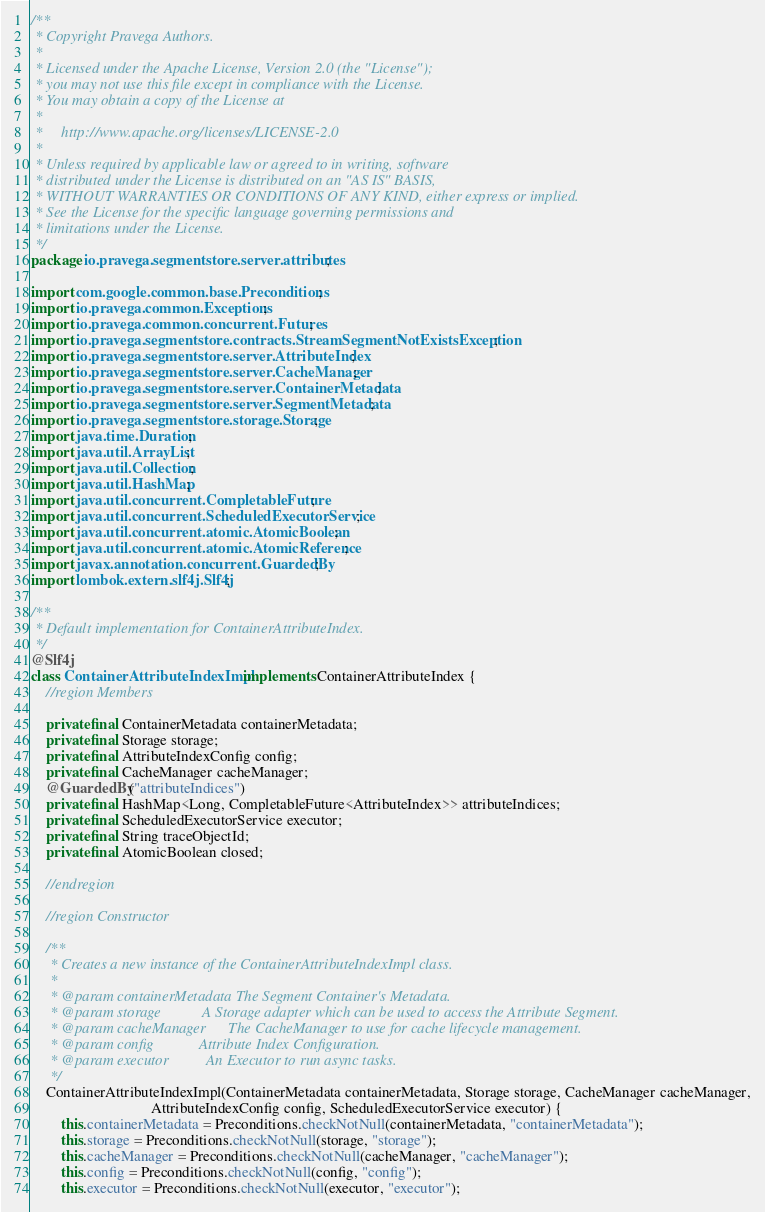<code> <loc_0><loc_0><loc_500><loc_500><_Java_>/**
 * Copyright Pravega Authors.
 *
 * Licensed under the Apache License, Version 2.0 (the "License");
 * you may not use this file except in compliance with the License.
 * You may obtain a copy of the License at
 *
 *     http://www.apache.org/licenses/LICENSE-2.0
 *
 * Unless required by applicable law or agreed to in writing, software
 * distributed under the License is distributed on an "AS IS" BASIS,
 * WITHOUT WARRANTIES OR CONDITIONS OF ANY KIND, either express or implied.
 * See the License for the specific language governing permissions and
 * limitations under the License.
 */
package io.pravega.segmentstore.server.attributes;

import com.google.common.base.Preconditions;
import io.pravega.common.Exceptions;
import io.pravega.common.concurrent.Futures;
import io.pravega.segmentstore.contracts.StreamSegmentNotExistsException;
import io.pravega.segmentstore.server.AttributeIndex;
import io.pravega.segmentstore.server.CacheManager;
import io.pravega.segmentstore.server.ContainerMetadata;
import io.pravega.segmentstore.server.SegmentMetadata;
import io.pravega.segmentstore.storage.Storage;
import java.time.Duration;
import java.util.ArrayList;
import java.util.Collection;
import java.util.HashMap;
import java.util.concurrent.CompletableFuture;
import java.util.concurrent.ScheduledExecutorService;
import java.util.concurrent.atomic.AtomicBoolean;
import java.util.concurrent.atomic.AtomicReference;
import javax.annotation.concurrent.GuardedBy;
import lombok.extern.slf4j.Slf4j;

/**
 * Default implementation for ContainerAttributeIndex.
 */
@Slf4j
class ContainerAttributeIndexImpl implements ContainerAttributeIndex {
    //region Members

    private final ContainerMetadata containerMetadata;
    private final Storage storage;
    private final AttributeIndexConfig config;
    private final CacheManager cacheManager;
    @GuardedBy("attributeIndices")
    private final HashMap<Long, CompletableFuture<AttributeIndex>> attributeIndices;
    private final ScheduledExecutorService executor;
    private final String traceObjectId;
    private final AtomicBoolean closed;

    //endregion

    //region Constructor

    /**
     * Creates a new instance of the ContainerAttributeIndexImpl class.
     *
     * @param containerMetadata The Segment Container's Metadata.
     * @param storage           A Storage adapter which can be used to access the Attribute Segment.
     * @param cacheManager      The CacheManager to use for cache lifecycle management.
     * @param config            Attribute Index Configuration.
     * @param executor          An Executor to run async tasks.
     */
    ContainerAttributeIndexImpl(ContainerMetadata containerMetadata, Storage storage, CacheManager cacheManager,
                                AttributeIndexConfig config, ScheduledExecutorService executor) {
        this.containerMetadata = Preconditions.checkNotNull(containerMetadata, "containerMetadata");
        this.storage = Preconditions.checkNotNull(storage, "storage");
        this.cacheManager = Preconditions.checkNotNull(cacheManager, "cacheManager");
        this.config = Preconditions.checkNotNull(config, "config");
        this.executor = Preconditions.checkNotNull(executor, "executor");</code> 